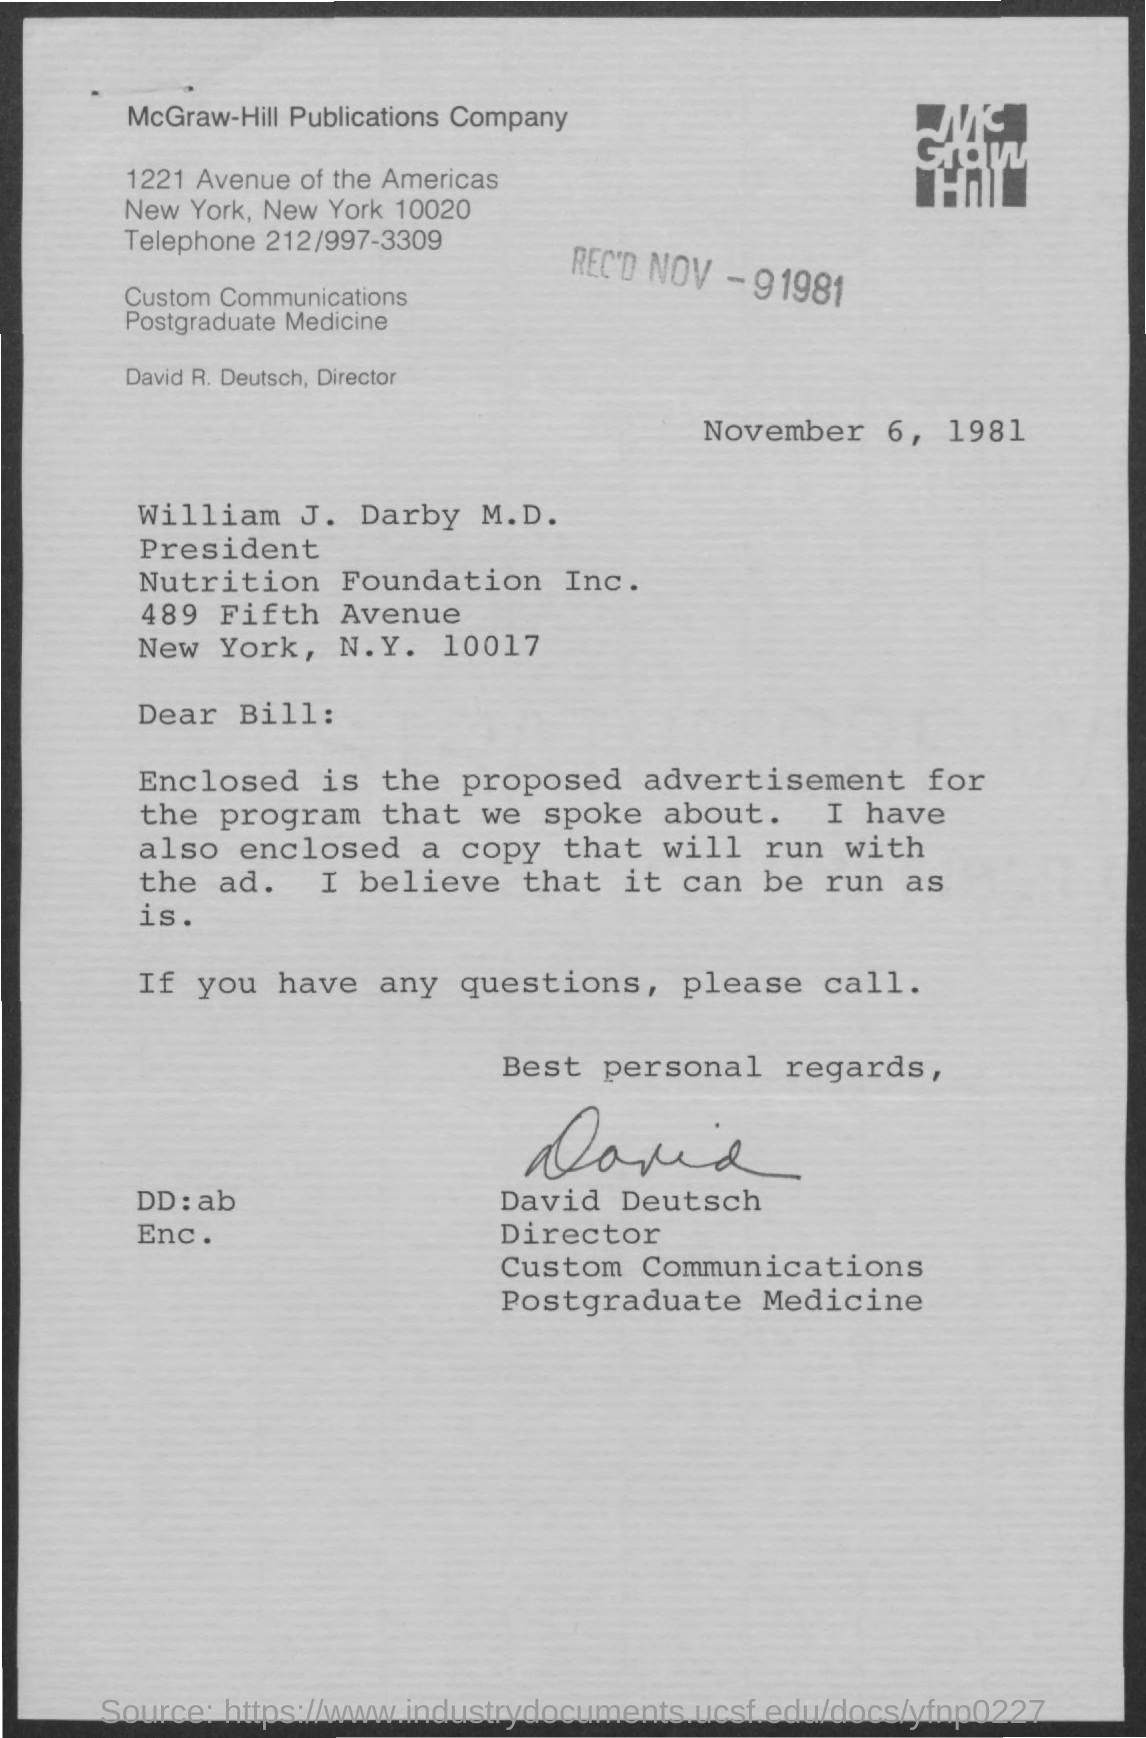What is date of the document?
Give a very brief answer. November 6, 1981. 